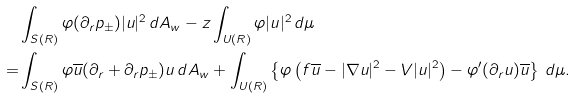<formula> <loc_0><loc_0><loc_500><loc_500>& \int _ { S ( R ) } \varphi ( \partial _ { r } p _ { \pm } ) | u | ^ { 2 } \, d A _ { w } - z \int _ { U ( R ) } \varphi | u | ^ { 2 } \, d \mu \\ = & \int _ { S ( R ) } \varphi \overline { u } ( \partial _ { r } + \partial _ { r } p _ { \pm } ) u \, d A _ { w } + \int _ { U ( R ) } \left \{ \varphi \left ( f \overline { u } - | \nabla u | ^ { 2 } - V | u | ^ { 2 } \right ) - \varphi ^ { \prime } ( \partial _ { r } u ) \overline { u } \right \} \, d \mu .</formula> 